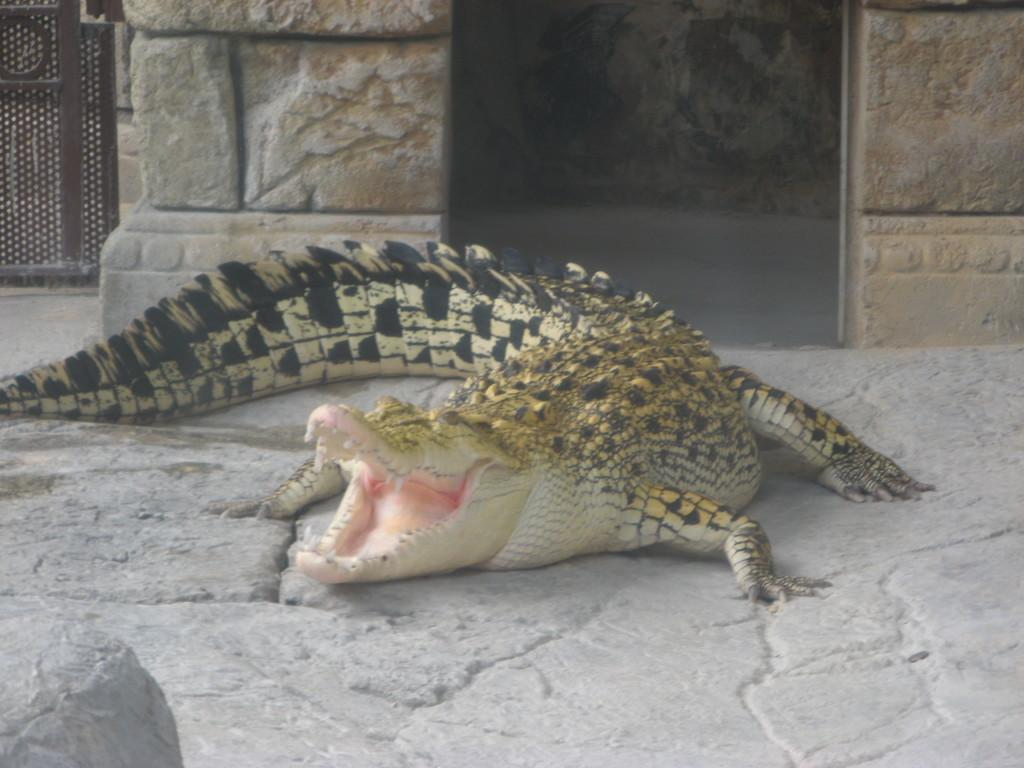What animal is present in the image? There is a crocodile in the image. Where is the crocodile located? The crocodile is on land. What colors can be seen on the crocodile? The crocodile has black and cream color. What can be seen in the background of the image? There is a wall in the background of the image. What type of space event is happening in the image? There is no space event present in the image; it features a crocodile on land with a wall in the background. Can you describe the alley where the crocodile is located? There is no alley present in the image; it is a crocodile on land with a wall in the background. 